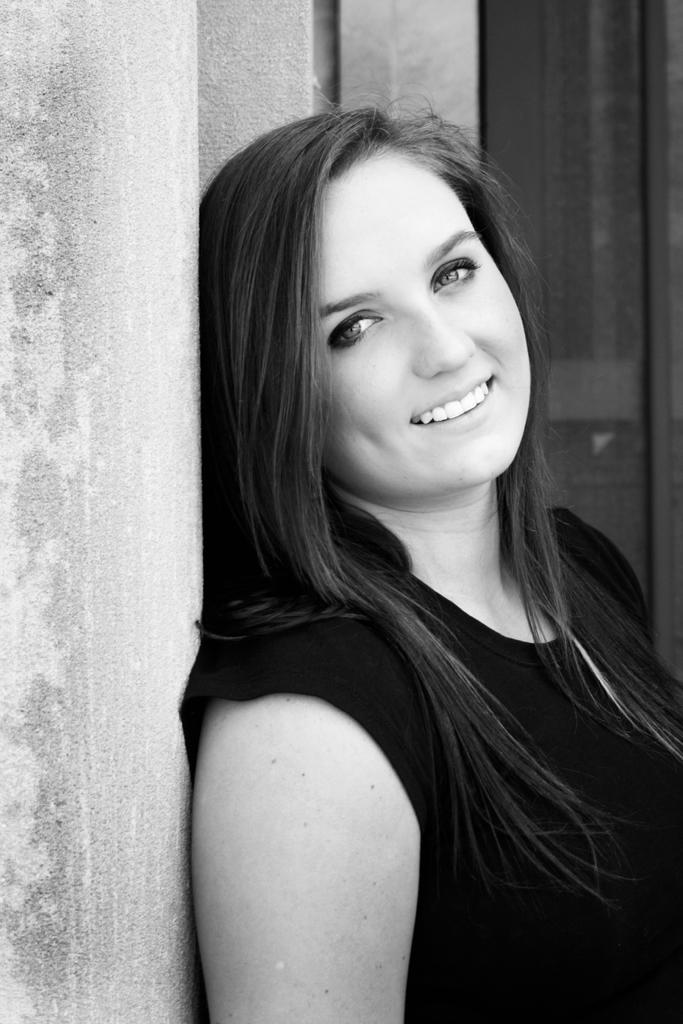What is the color scheme of the image? The image is black and white. Who is the main subject in the image? There is a woman in the center of the image. What is the woman's expression in the image? The woman is smiling. What can be seen on the left side of the image? There is a wall on the left side of the image. What architectural feature is visible in the background of the image? There is a door in the background of the image. What type of cloud can be seen in the image? There are no clouds present in the image, as it is a black and white photograph. 